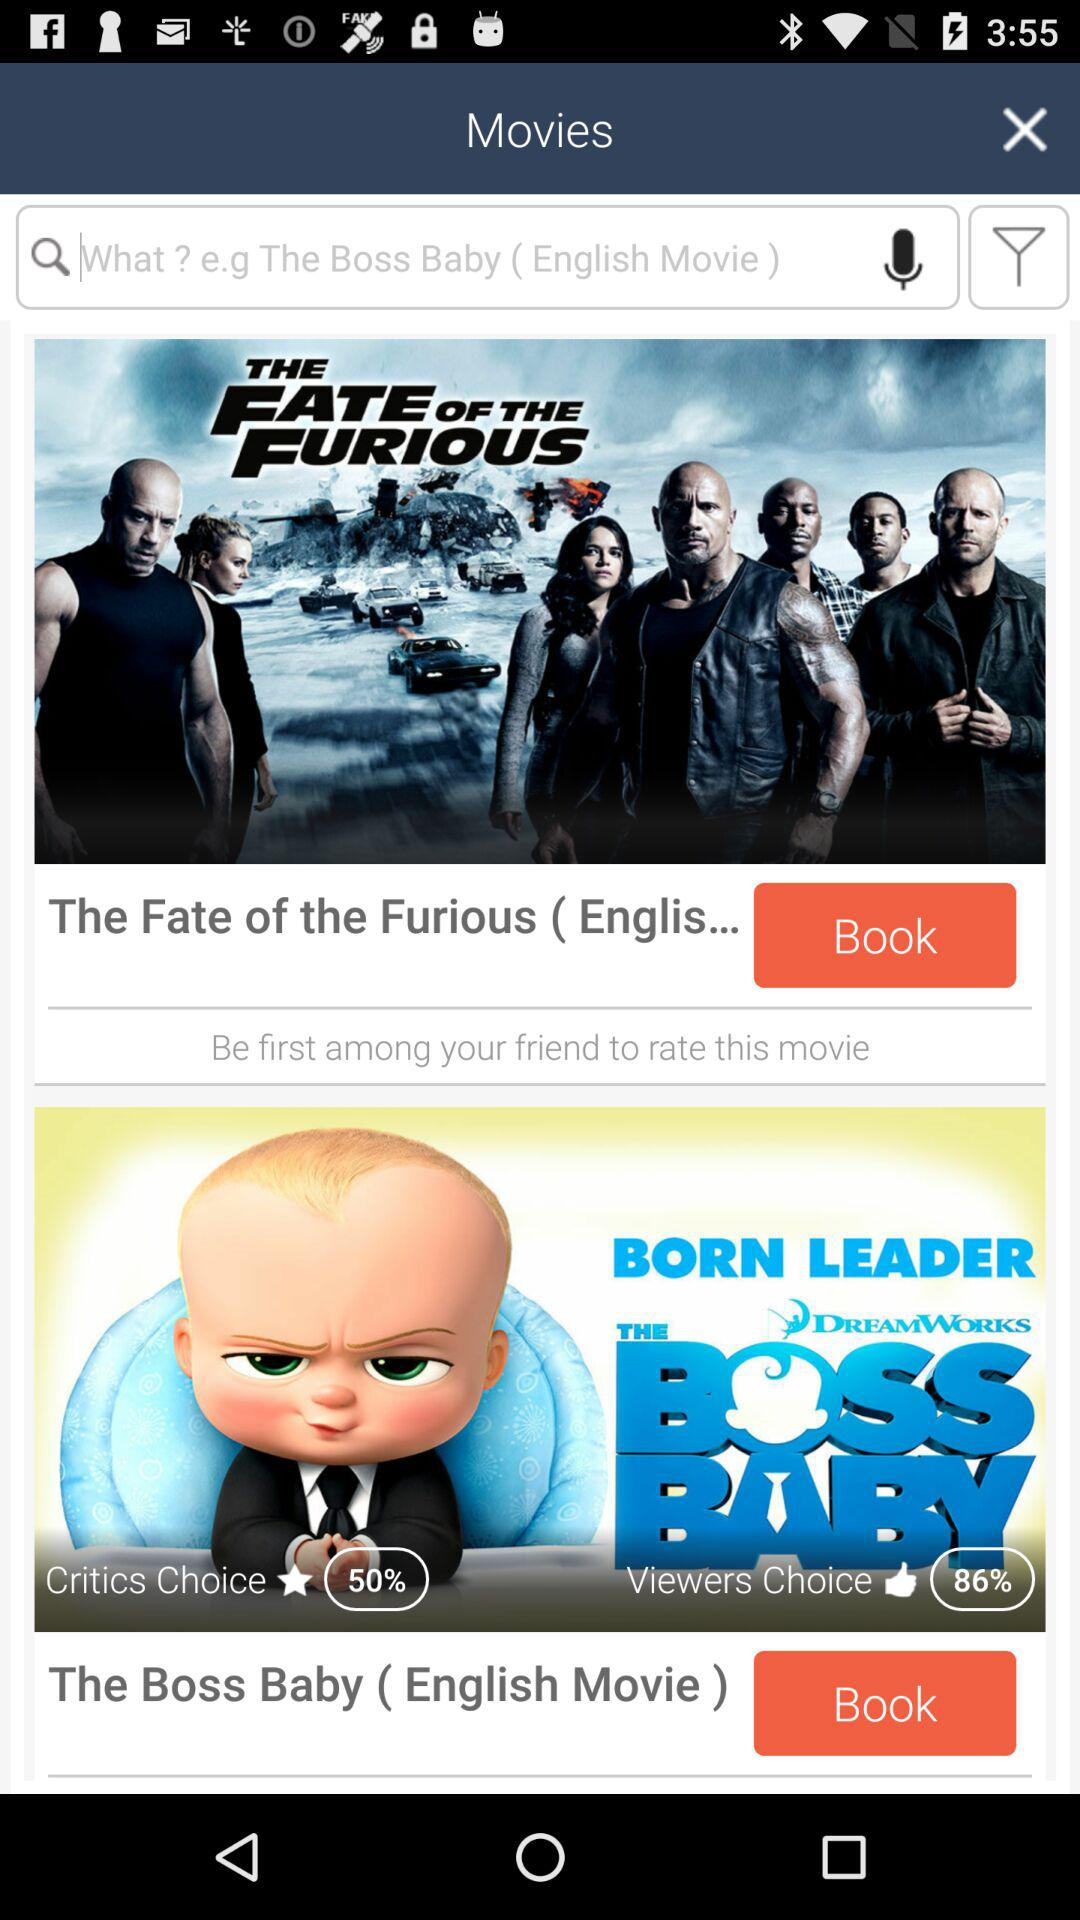How many movie posters are shown on the screen?
Answer the question using a single word or phrase. 2 